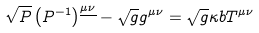Convert formula to latex. <formula><loc_0><loc_0><loc_500><loc_500>\sqrt { P } \left ( P ^ { - 1 } \right ) ^ { \underline { \mu \nu } } - \sqrt { g } g ^ { \mu \nu } = \sqrt { g } \kappa b T ^ { \mu \nu }</formula> 